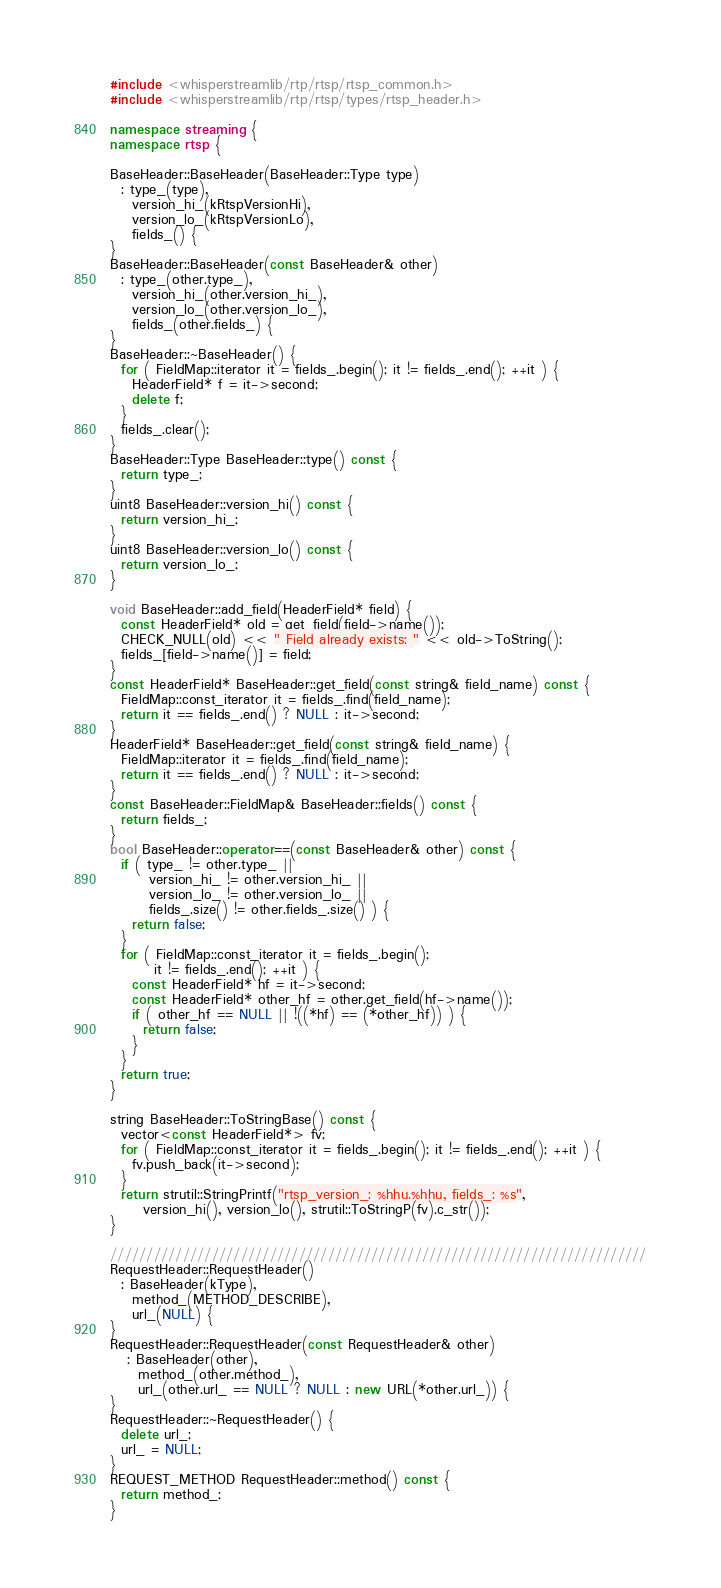Convert code to text. <code><loc_0><loc_0><loc_500><loc_500><_C++_>
#include <whisperstreamlib/rtp/rtsp/rtsp_common.h>
#include <whisperstreamlib/rtp/rtsp/types/rtsp_header.h>

namespace streaming {
namespace rtsp {

BaseHeader::BaseHeader(BaseHeader::Type type)
  : type_(type),
    version_hi_(kRtspVersionHi),
    version_lo_(kRtspVersionLo),
    fields_() {
}
BaseHeader::BaseHeader(const BaseHeader& other)
  : type_(other.type_),
    version_hi_(other.version_hi_),
    version_lo_(other.version_lo_),
    fields_(other.fields_) {
}
BaseHeader::~BaseHeader() {
  for ( FieldMap::iterator it = fields_.begin(); it != fields_.end(); ++it ) {
    HeaderField* f = it->second;
    delete f;
  }
  fields_.clear();
}
BaseHeader::Type BaseHeader::type() const {
  return type_;
}
uint8 BaseHeader::version_hi() const {
  return version_hi_;
}
uint8 BaseHeader::version_lo() const {
  return version_lo_;
}

void BaseHeader::add_field(HeaderField* field) {
  const HeaderField* old = get_field(field->name());
  CHECK_NULL(old) << " Field already exists: " << old->ToString();
  fields_[field->name()] = field;
}
const HeaderField* BaseHeader::get_field(const string& field_name) const {
  FieldMap::const_iterator it = fields_.find(field_name);
  return it == fields_.end() ? NULL : it->second;
}
HeaderField* BaseHeader::get_field(const string& field_name) {
  FieldMap::iterator it = fields_.find(field_name);
  return it == fields_.end() ? NULL : it->second;
}
const BaseHeader::FieldMap& BaseHeader::fields() const {
  return fields_;
}
bool BaseHeader::operator==(const BaseHeader& other) const {
  if ( type_ != other.type_ ||
       version_hi_ != other.version_hi_ ||
       version_lo_ != other.version_lo_ ||
       fields_.size() != other.fields_.size() ) {
    return false;
  }
  for ( FieldMap::const_iterator it = fields_.begin();
        it != fields_.end(); ++it ) {
    const HeaderField* hf = it->second;
    const HeaderField* other_hf = other.get_field(hf->name());
    if ( other_hf == NULL || !((*hf) == (*other_hf)) ) {
      return false;
    }
  }
  return true;
}

string BaseHeader::ToStringBase() const {
  vector<const HeaderField*> fv;
  for ( FieldMap::const_iterator it = fields_.begin(); it != fields_.end(); ++it ) {
    fv.push_back(it->second);
  }
  return strutil::StringPrintf("rtsp_version_: %hhu.%hhu, fields_: %s",
      version_hi(), version_lo(), strutil::ToStringP(fv).c_str());
}

//////////////////////////////////////////////////////////////////////////
RequestHeader::RequestHeader()
  : BaseHeader(kType),
    method_(METHOD_DESCRIBE),
    url_(NULL) {
}
RequestHeader::RequestHeader(const RequestHeader& other)
   : BaseHeader(other),
     method_(other.method_),
     url_(other.url_ == NULL ? NULL : new URL(*other.url_)) {
}
RequestHeader::~RequestHeader() {
  delete url_;
  url_ = NULL;
}
REQUEST_METHOD RequestHeader::method() const {
  return method_;
}</code> 